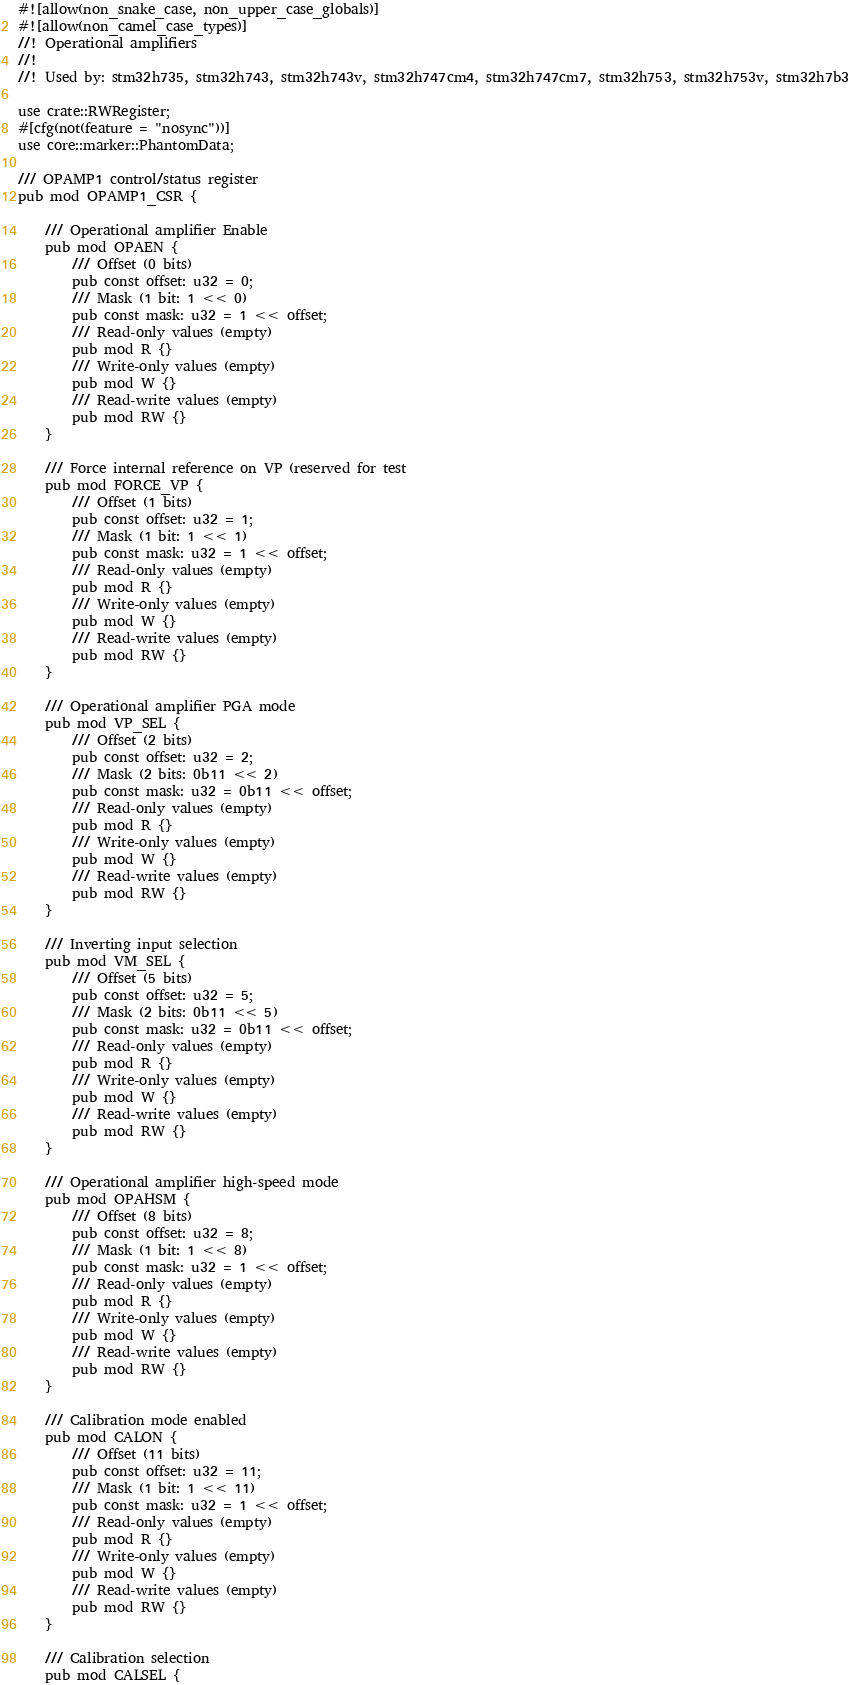<code> <loc_0><loc_0><loc_500><loc_500><_Rust_>#![allow(non_snake_case, non_upper_case_globals)]
#![allow(non_camel_case_types)]
//! Operational amplifiers
//!
//! Used by: stm32h735, stm32h743, stm32h743v, stm32h747cm4, stm32h747cm7, stm32h753, stm32h753v, stm32h7b3

use crate::RWRegister;
#[cfg(not(feature = "nosync"))]
use core::marker::PhantomData;

/// OPAMP1 control/status register
pub mod OPAMP1_CSR {

    /// Operational amplifier Enable
    pub mod OPAEN {
        /// Offset (0 bits)
        pub const offset: u32 = 0;
        /// Mask (1 bit: 1 << 0)
        pub const mask: u32 = 1 << offset;
        /// Read-only values (empty)
        pub mod R {}
        /// Write-only values (empty)
        pub mod W {}
        /// Read-write values (empty)
        pub mod RW {}
    }

    /// Force internal reference on VP (reserved for test
    pub mod FORCE_VP {
        /// Offset (1 bits)
        pub const offset: u32 = 1;
        /// Mask (1 bit: 1 << 1)
        pub const mask: u32 = 1 << offset;
        /// Read-only values (empty)
        pub mod R {}
        /// Write-only values (empty)
        pub mod W {}
        /// Read-write values (empty)
        pub mod RW {}
    }

    /// Operational amplifier PGA mode
    pub mod VP_SEL {
        /// Offset (2 bits)
        pub const offset: u32 = 2;
        /// Mask (2 bits: 0b11 << 2)
        pub const mask: u32 = 0b11 << offset;
        /// Read-only values (empty)
        pub mod R {}
        /// Write-only values (empty)
        pub mod W {}
        /// Read-write values (empty)
        pub mod RW {}
    }

    /// Inverting input selection
    pub mod VM_SEL {
        /// Offset (5 bits)
        pub const offset: u32 = 5;
        /// Mask (2 bits: 0b11 << 5)
        pub const mask: u32 = 0b11 << offset;
        /// Read-only values (empty)
        pub mod R {}
        /// Write-only values (empty)
        pub mod W {}
        /// Read-write values (empty)
        pub mod RW {}
    }

    /// Operational amplifier high-speed mode
    pub mod OPAHSM {
        /// Offset (8 bits)
        pub const offset: u32 = 8;
        /// Mask (1 bit: 1 << 8)
        pub const mask: u32 = 1 << offset;
        /// Read-only values (empty)
        pub mod R {}
        /// Write-only values (empty)
        pub mod W {}
        /// Read-write values (empty)
        pub mod RW {}
    }

    /// Calibration mode enabled
    pub mod CALON {
        /// Offset (11 bits)
        pub const offset: u32 = 11;
        /// Mask (1 bit: 1 << 11)
        pub const mask: u32 = 1 << offset;
        /// Read-only values (empty)
        pub mod R {}
        /// Write-only values (empty)
        pub mod W {}
        /// Read-write values (empty)
        pub mod RW {}
    }

    /// Calibration selection
    pub mod CALSEL {</code> 